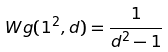Convert formula to latex. <formula><loc_0><loc_0><loc_500><loc_500>W g ( 1 ^ { 2 } , d ) = \frac { 1 } { d ^ { 2 } - 1 }</formula> 